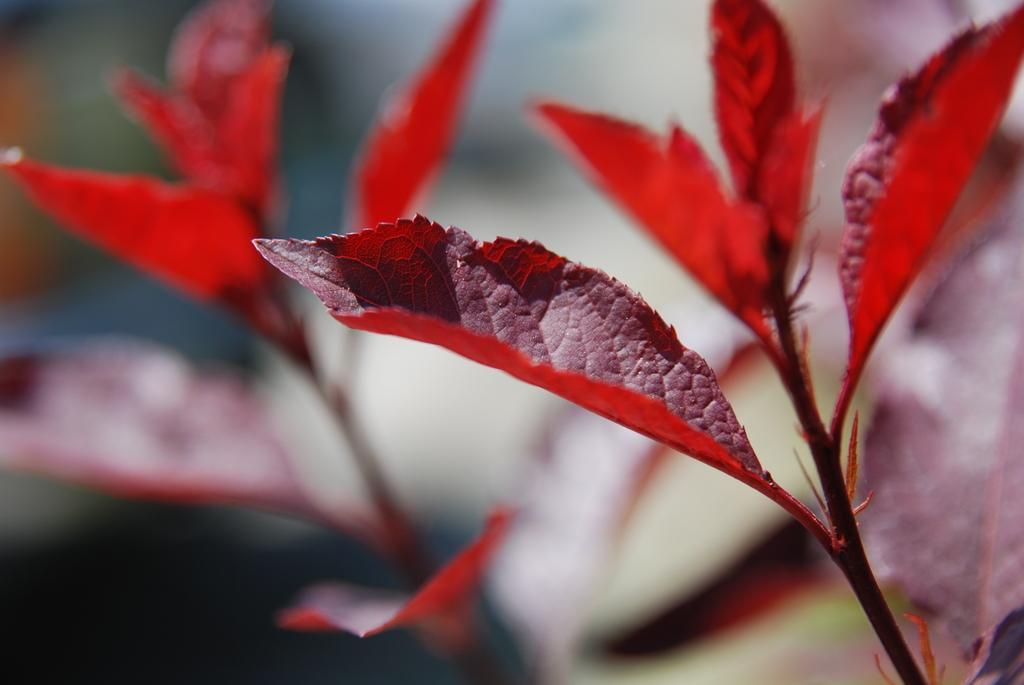Can you describe this image briefly? In this image, we can see some leaves and the background is blurred. 